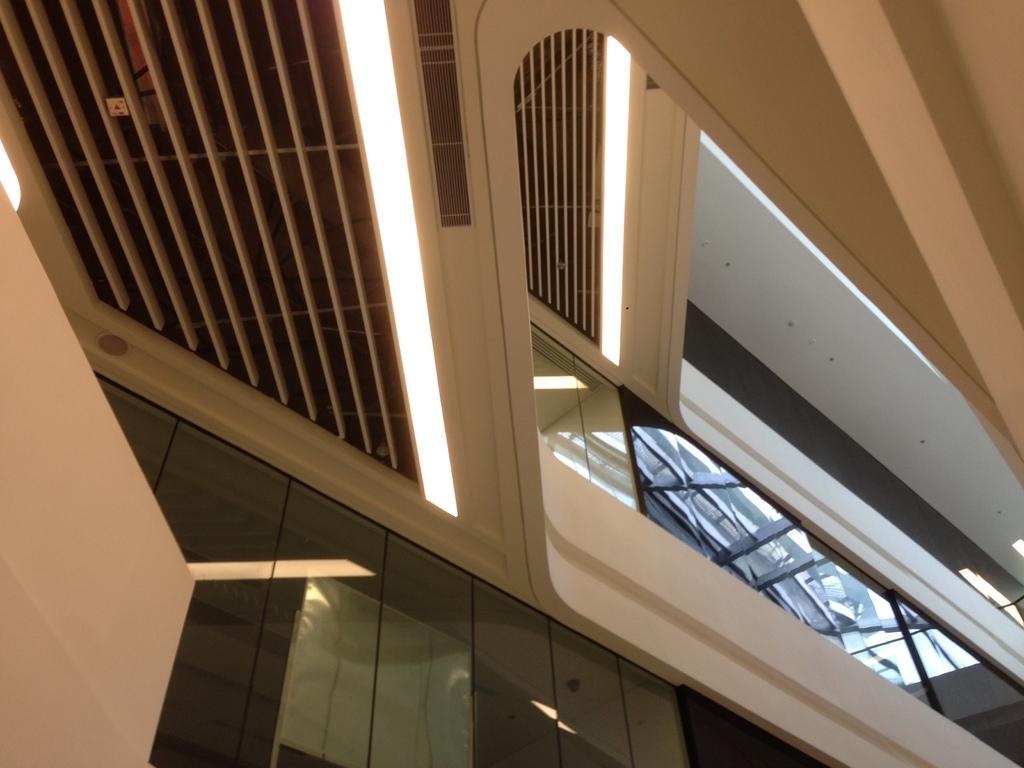Can you describe this image briefly? I think this is the inside view of a building. These are the air conditioners and the lights. At the bottom of the image, I can see the glass doors with the reflection of the lights on it. These are the walls. 